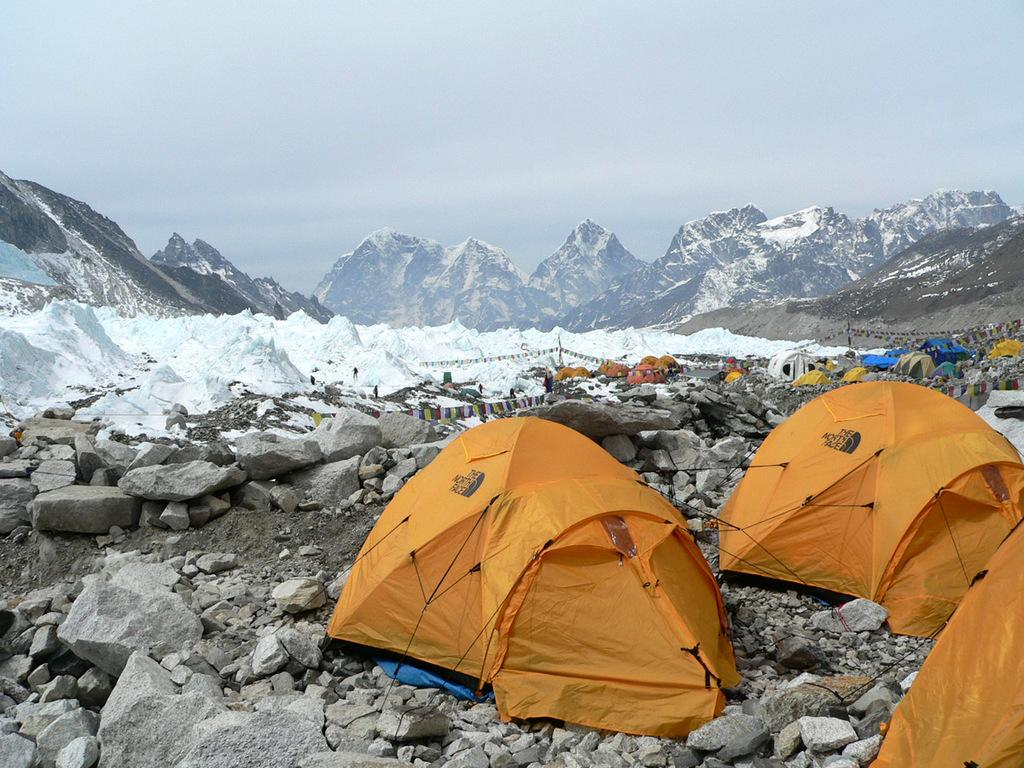What type of weather condition is depicted in the image? There is snow in the image, indicating a cold and wintry scene. What natural features can be seen in the image? There are mountains in the image. What type of temporary shelter is present in the image? There are tents in the image. What type of ground surface is visible in the image? There are stones in the image. What is visible above the ground in the image? The sky is visible in the image. What grade of meat is being cooked in the image? There is no meat or cooking activity present in the image; it features snow, mountains, tents, stones, and the sky. 